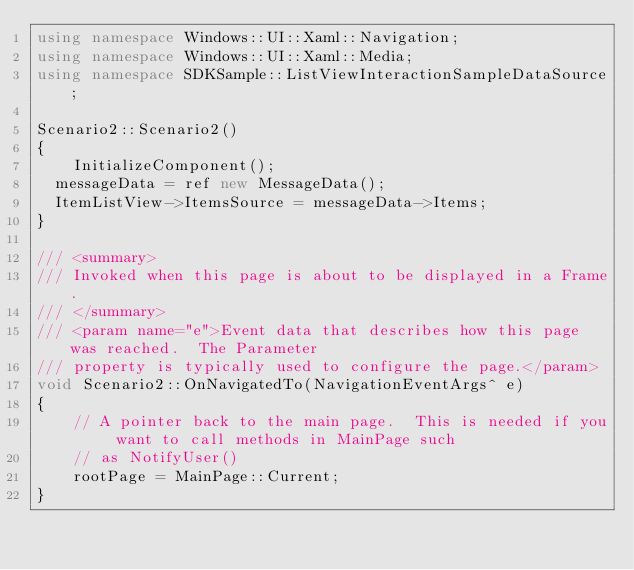<code> <loc_0><loc_0><loc_500><loc_500><_C++_>using namespace Windows::UI::Xaml::Navigation;
using namespace Windows::UI::Xaml::Media;
using namespace SDKSample::ListViewInteractionSampleDataSource;

Scenario2::Scenario2()
{
    InitializeComponent();
	messageData = ref new MessageData();
	ItemListView->ItemsSource = messageData->Items;
}

/// <summary>
/// Invoked when this page is about to be displayed in a Frame.
/// </summary>
/// <param name="e">Event data that describes how this page was reached.  The Parameter
/// property is typically used to configure the page.</param>
void Scenario2::OnNavigatedTo(NavigationEventArgs^ e)
{
    // A pointer back to the main page.  This is needed if you want to call methods in MainPage such
    // as NotifyUser()
    rootPage = MainPage::Current;
}


</code> 